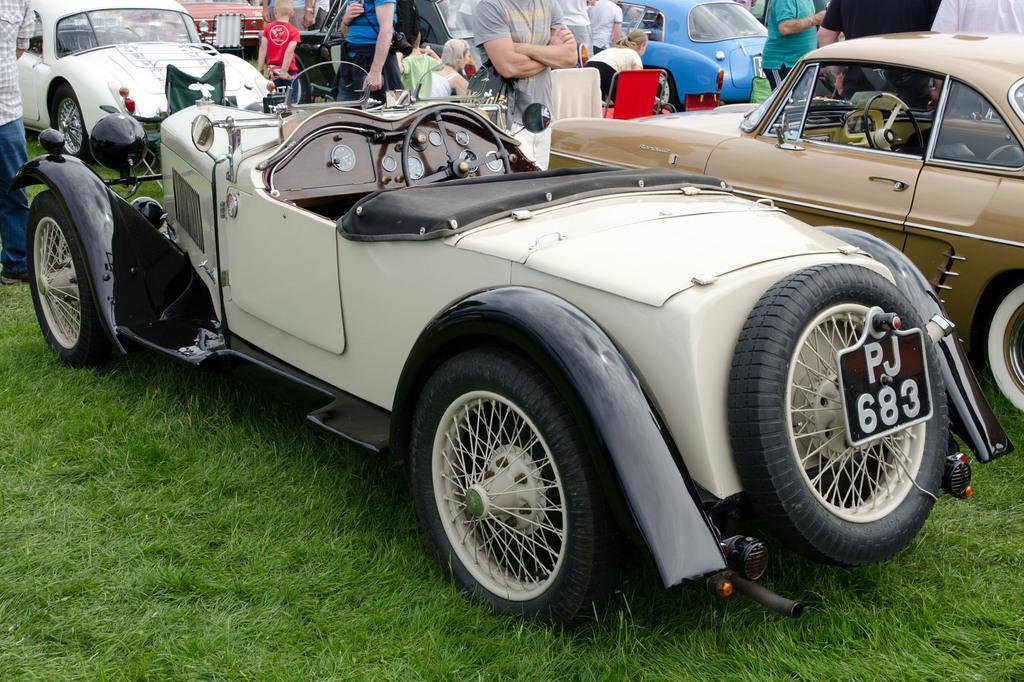Please provide a concise description of this image. In this picture I see the grass in front and I see number of cars and people and I see that few of them are sitting on chairs and I see a board on the car which is in front and I see alphabets and numbers written on it. 